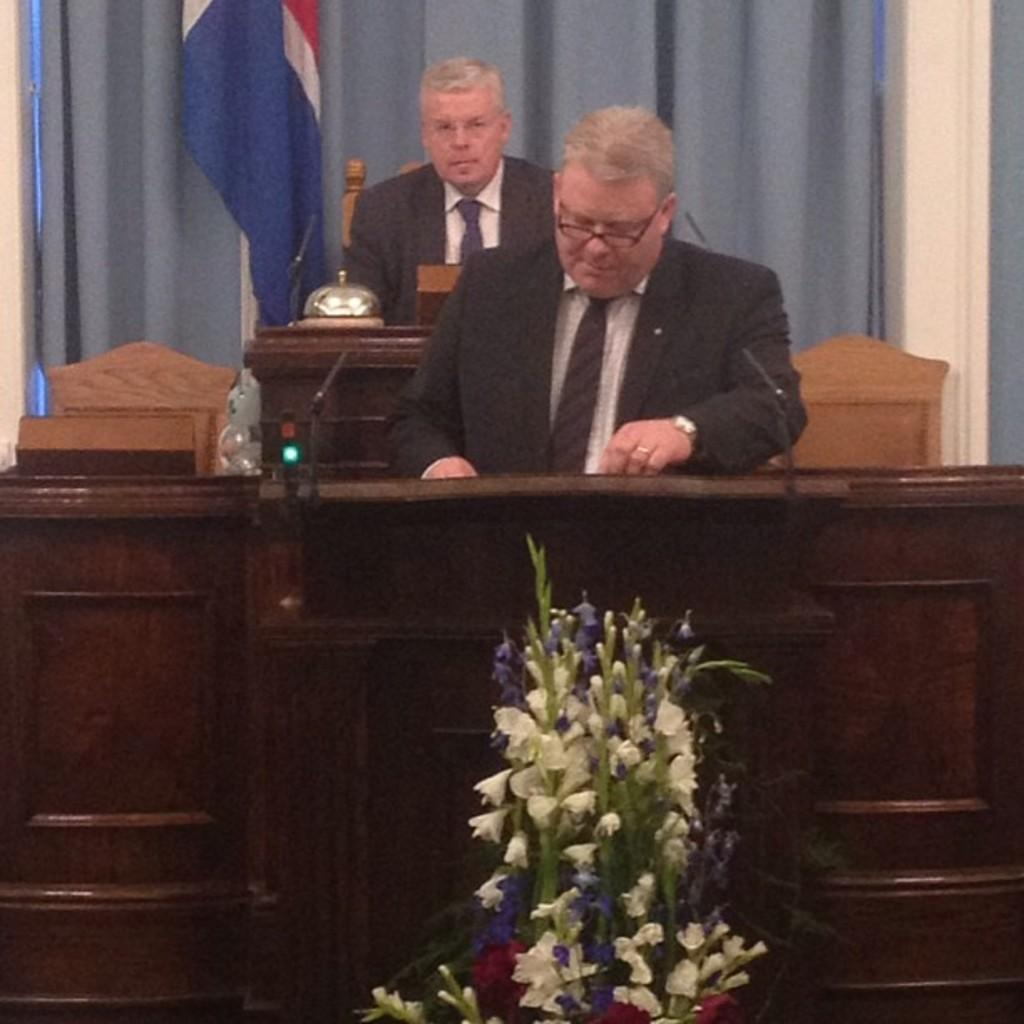How many people are in the image? There are two persons in the image. What are the persons doing in the image? The persons are standing in front of a podium. What can be seen on the podium? Flowers are present on the podium, and two microphones are attached to it. What is visible in the background of the image? There is a flag and curtains visible in the background of the image. What type of slope can be seen in the image? There is no slope present in the image. What process is being carried out by the persons in the image? The image does not provide enough information to determine the specific process being carried out by the persons. 